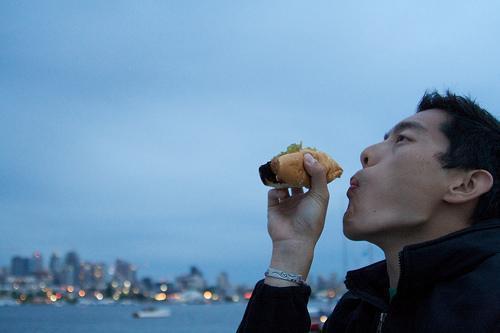How many boats are in the water?
Give a very brief answer. 9. 